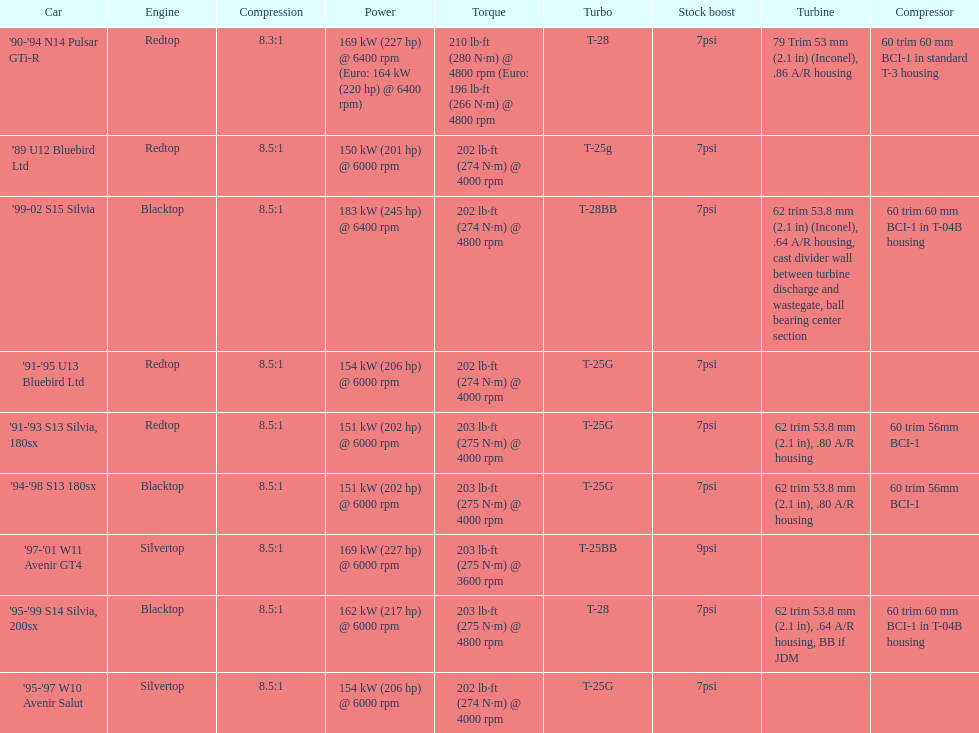Which engine(s) has the least amount of power? Redtop. 